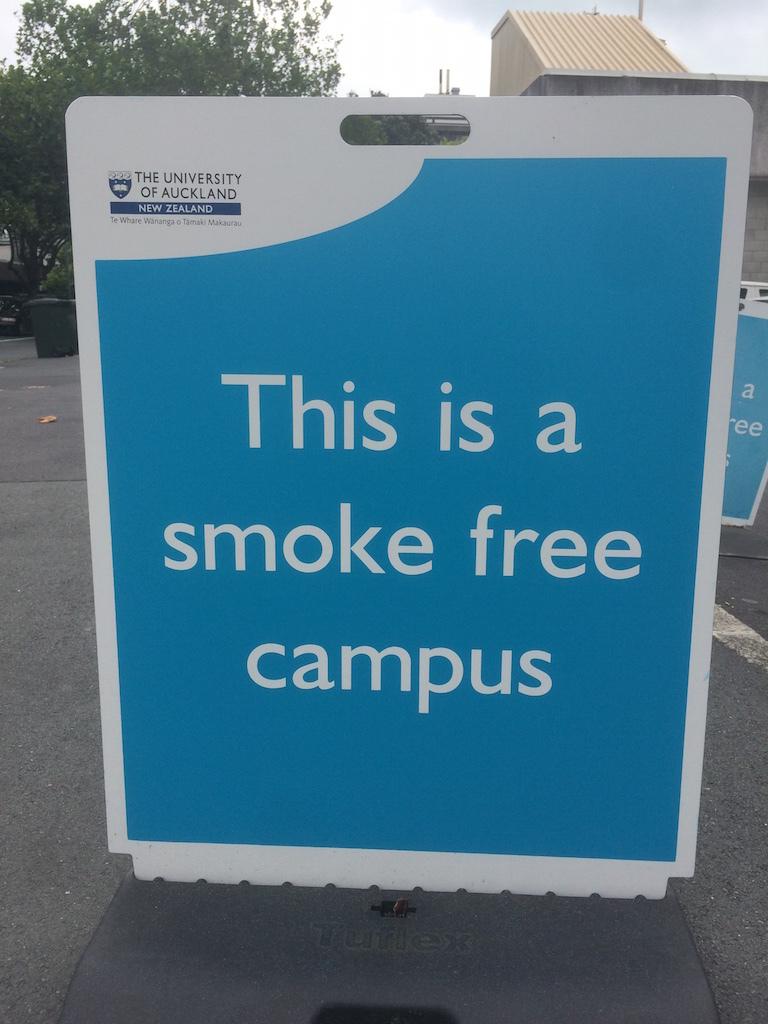What is note allowed on campus?
Your answer should be very brief. Smoking. What color is the note?
Offer a terse response. Blue. 